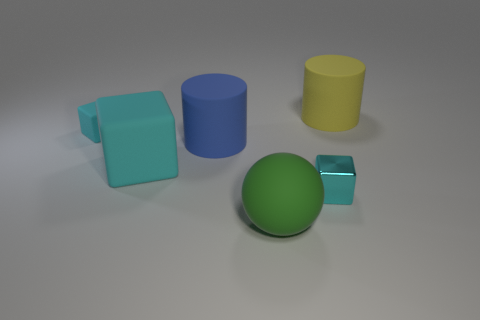Subtract 1 cubes. How many cubes are left? 2 Add 3 tiny matte blocks. How many objects exist? 9 Subtract all cylinders. How many objects are left? 4 Add 4 small shiny blocks. How many small shiny blocks exist? 5 Subtract 0 purple spheres. How many objects are left? 6 Subtract all tiny cyan objects. Subtract all green matte balls. How many objects are left? 3 Add 5 large rubber cylinders. How many large rubber cylinders are left? 7 